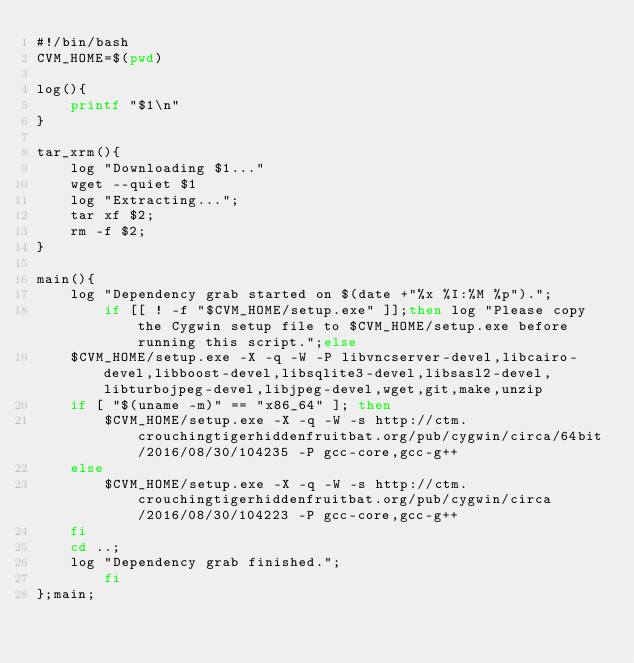Convert code to text. <code><loc_0><loc_0><loc_500><loc_500><_Bash_>#!/bin/bash
CVM_HOME=$(pwd)

log(){
	printf "$1\n"
}

tar_xrm(){
	log "Downloading $1..."
	wget --quiet $1
	log "Extracting...";
	tar xf $2;
	rm -f $2;
}

main(){
	log "Dependency grab started on $(date +"%x %I:%M %p").";
        if [[ ! -f "$CVM_HOME/setup.exe" ]];then log "Please copy the Cygwin setup file to $CVM_HOME/setup.exe before running this script.";else
	$CVM_HOME/setup.exe -X -q -W -P libvncserver-devel,libcairo-devel,libboost-devel,libsqlite3-devel,libsasl2-devel,libturbojpeg-devel,libjpeg-devel,wget,git,make,unzip
	if [ "$(uname -m)" == "x86_64" ]; then
		$CVM_HOME/setup.exe -X -q -W -s http://ctm.crouchingtigerhiddenfruitbat.org/pub/cygwin/circa/64bit/2016/08/30/104235 -P gcc-core,gcc-g++
	else
		$CVM_HOME/setup.exe -X -q -W -s http://ctm.crouchingtigerhiddenfruitbat.org/pub/cygwin/circa/2016/08/30/104223 -P gcc-core,gcc-g++
	fi
	cd ..;
	log "Dependency grab finished.";
        fi
};main;
</code> 